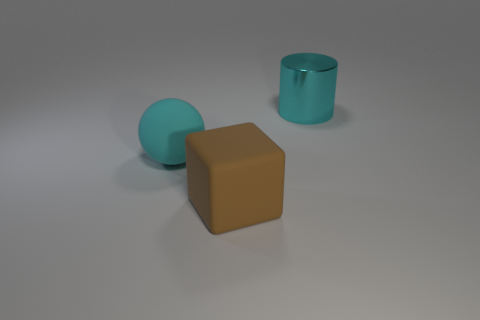Are there fewer metal objects on the right side of the brown matte object than metallic cylinders to the left of the cyan sphere?
Make the answer very short. No. Are there any other things that are the same size as the cyan matte sphere?
Your answer should be very brief. Yes. What shape is the cyan metallic object?
Provide a short and direct response. Cylinder. What material is the cyan thing to the left of the large cyan shiny thing?
Provide a short and direct response. Rubber. There is a cyan object to the left of the big cyan thing that is on the right side of the cyan object that is left of the big cyan cylinder; what size is it?
Give a very brief answer. Large. Are the large cyan thing that is to the left of the large cyan metallic cylinder and the brown object right of the matte ball made of the same material?
Offer a very short reply. Yes. How many other things are the same color as the cylinder?
Make the answer very short. 1. How many objects are large things that are in front of the big cyan metal object or cyan things that are in front of the big cylinder?
Make the answer very short. 2. What is the size of the thing behind the big cyan object that is left of the cylinder?
Your answer should be very brief. Large. The cube is what size?
Provide a succinct answer. Large. 